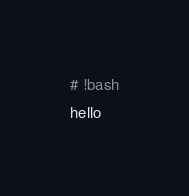<code> <loc_0><loc_0><loc_500><loc_500><_Bash_># !bash
hello
</code> 